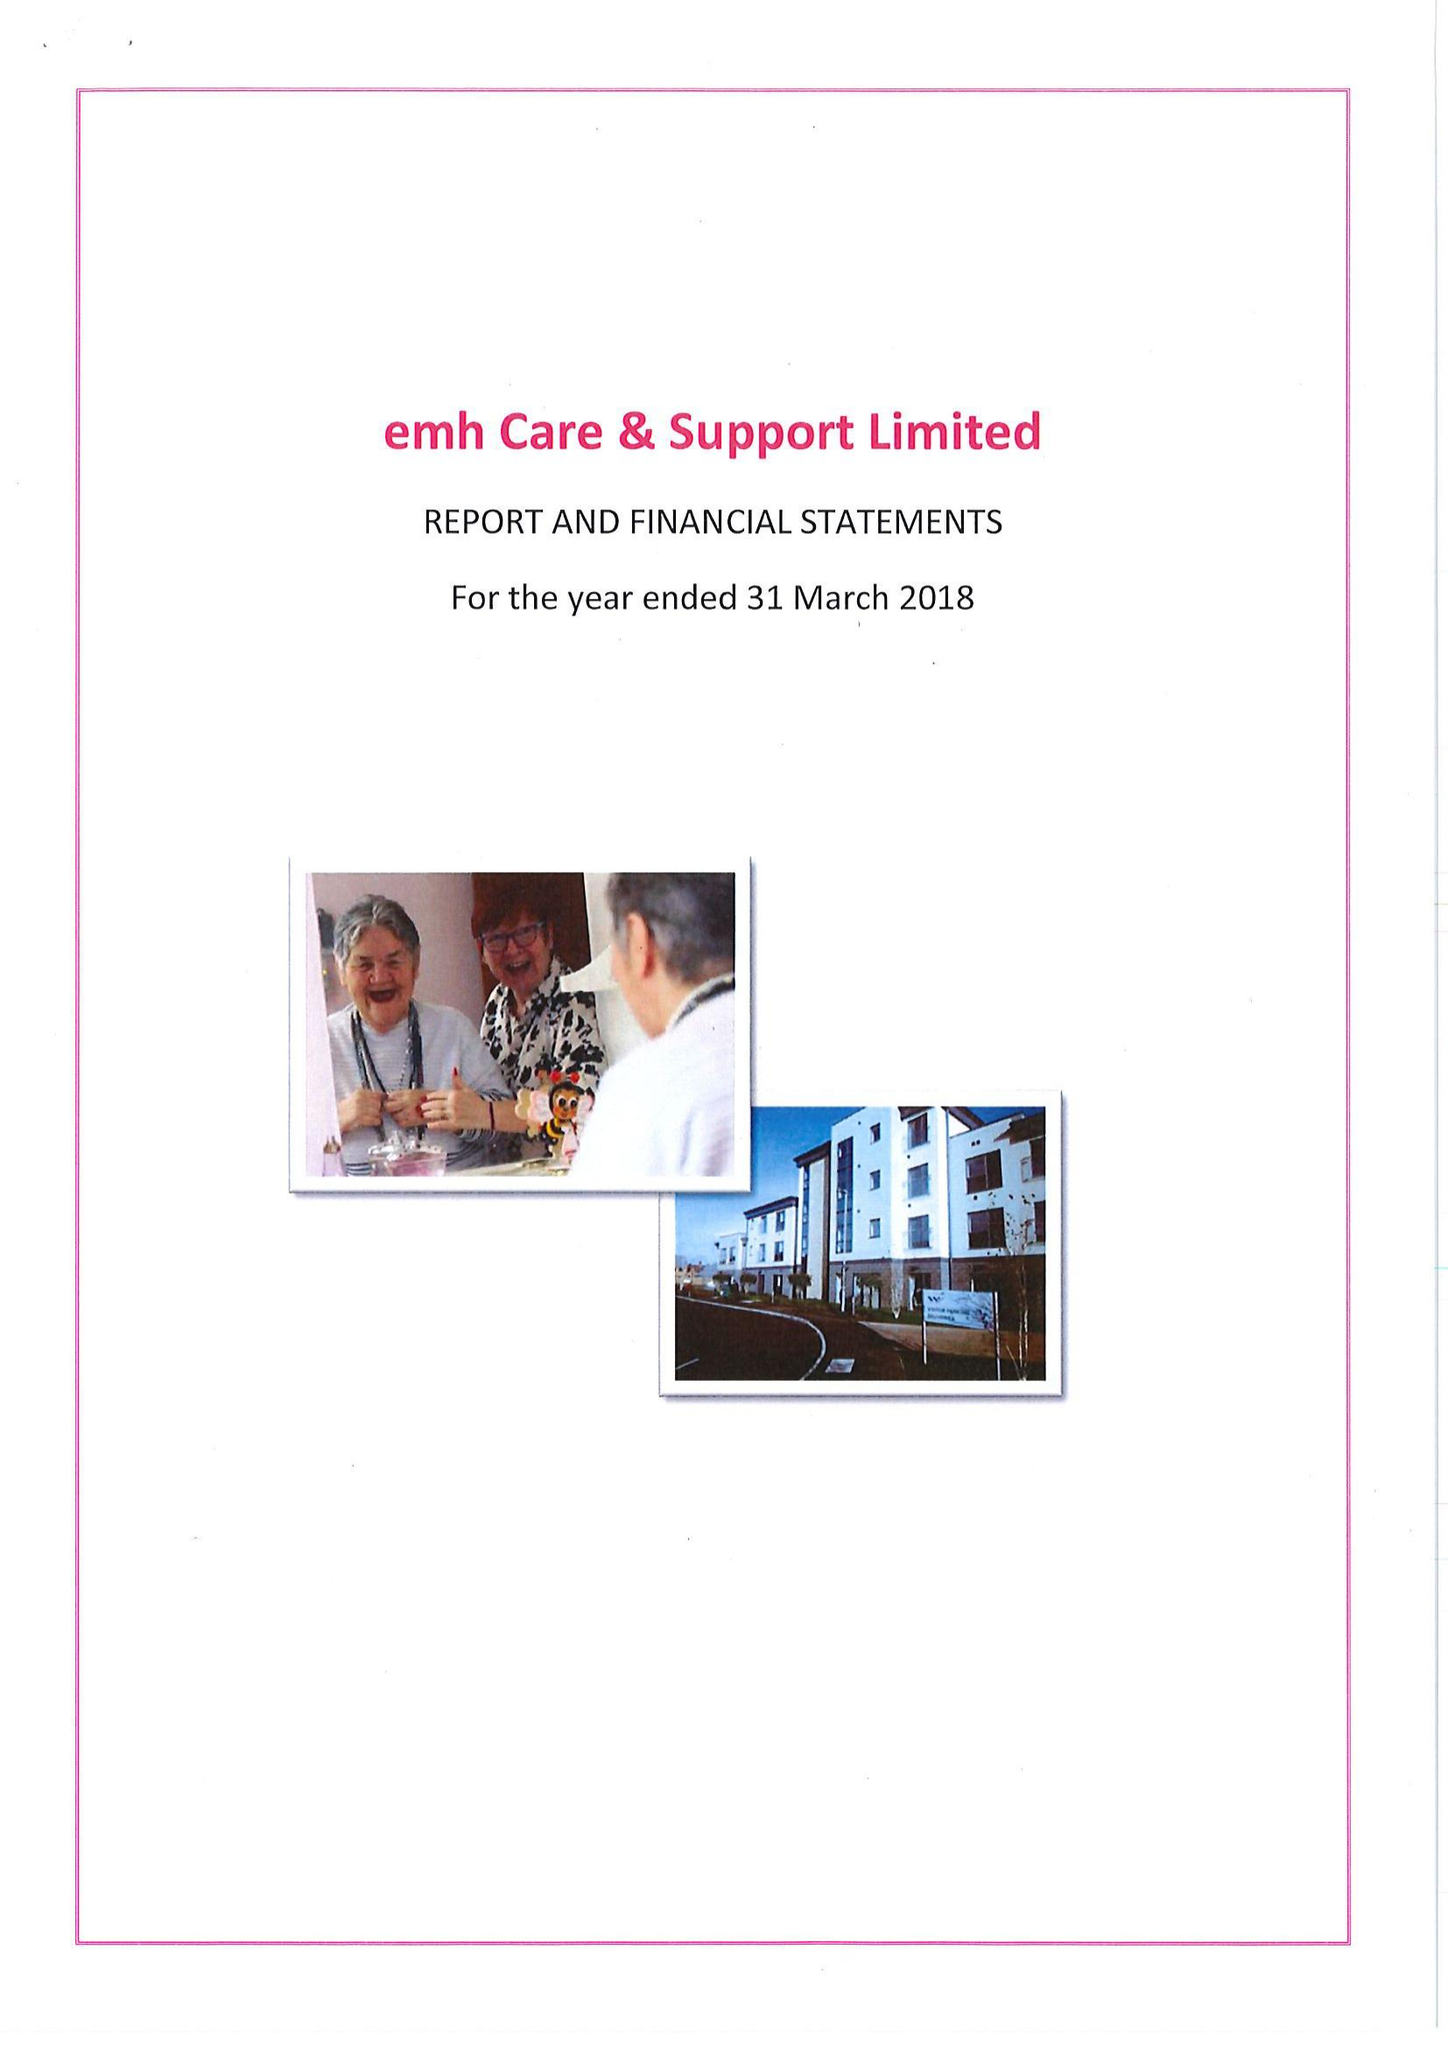What is the value for the income_annually_in_british_pounds?
Answer the question using a single word or phrase. 16725000.00 